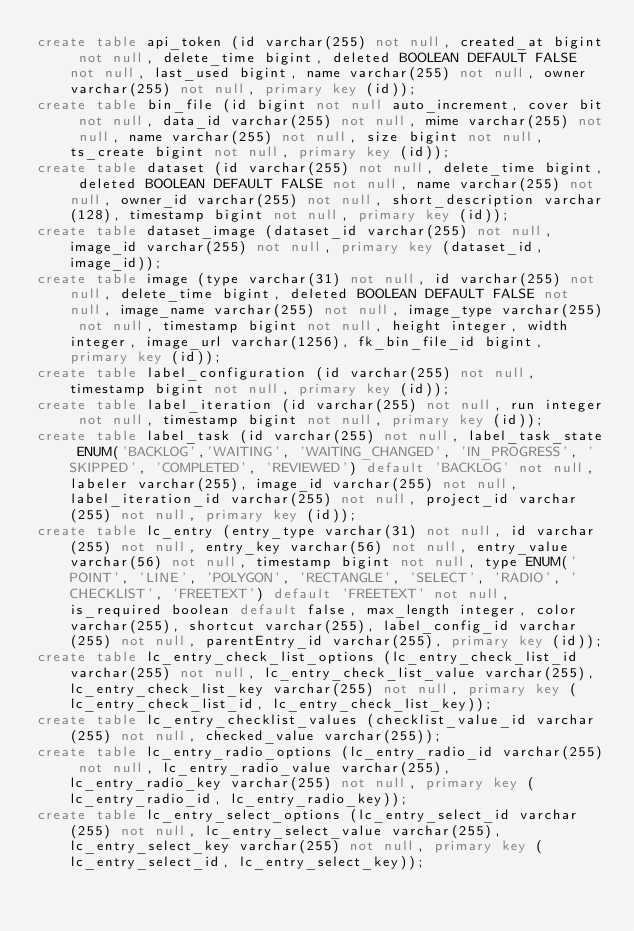Convert code to text. <code><loc_0><loc_0><loc_500><loc_500><_SQL_>create table api_token (id varchar(255) not null, created_at bigint not null, delete_time bigint, deleted BOOLEAN DEFAULT FALSE not null, last_used bigint, name varchar(255) not null, owner varchar(255) not null, primary key (id));
create table bin_file (id bigint not null auto_increment, cover bit not null, data_id varchar(255) not null, mime varchar(255) not null, name varchar(255) not null, size bigint not null, ts_create bigint not null, primary key (id));
create table dataset (id varchar(255) not null, delete_time bigint, deleted BOOLEAN DEFAULT FALSE not null, name varchar(255) not null, owner_id varchar(255) not null, short_description varchar(128), timestamp bigint not null, primary key (id));
create table dataset_image (dataset_id varchar(255) not null, image_id varchar(255) not null, primary key (dataset_id, image_id));
create table image (type varchar(31) not null, id varchar(255) not null, delete_time bigint, deleted BOOLEAN DEFAULT FALSE not null, image_name varchar(255) not null, image_type varchar(255) not null, timestamp bigint not null, height integer, width integer, image_url varchar(1256), fk_bin_file_id bigint, primary key (id));
create table label_configuration (id varchar(255) not null, timestamp bigint not null, primary key (id));
create table label_iteration (id varchar(255) not null, run integer not null, timestamp bigint not null, primary key (id));
create table label_task (id varchar(255) not null, label_task_state ENUM('BACKLOG','WAITING', 'WAITING_CHANGED', 'IN_PROGRESS', 'SKIPPED', 'COMPLETED', 'REVIEWED') default 'BACKLOG' not null, labeler varchar(255), image_id varchar(255) not null, label_iteration_id varchar(255) not null, project_id varchar(255) not null, primary key (id));
create table lc_entry (entry_type varchar(31) not null, id varchar(255) not null, entry_key varchar(56) not null, entry_value varchar(56) not null, timestamp bigint not null, type ENUM('POINT', 'LINE', 'POLYGON', 'RECTANGLE', 'SELECT', 'RADIO', 'CHECKLIST', 'FREETEXT') default 'FREETEXT' not null, is_required boolean default false, max_length integer, color varchar(255), shortcut varchar(255), label_config_id varchar(255) not null, parentEntry_id varchar(255), primary key (id));
create table lc_entry_check_list_options (lc_entry_check_list_id varchar(255) not null, lc_entry_check_list_value varchar(255), lc_entry_check_list_key varchar(255) not null, primary key (lc_entry_check_list_id, lc_entry_check_list_key));
create table lc_entry_checklist_values (checklist_value_id varchar(255) not null, checked_value varchar(255));
create table lc_entry_radio_options (lc_entry_radio_id varchar(255) not null, lc_entry_radio_value varchar(255), lc_entry_radio_key varchar(255) not null, primary key (lc_entry_radio_id, lc_entry_radio_key));
create table lc_entry_select_options (lc_entry_select_id varchar(255) not null, lc_entry_select_value varchar(255), lc_entry_select_key varchar(255) not null, primary key (lc_entry_select_id, lc_entry_select_key));</code> 